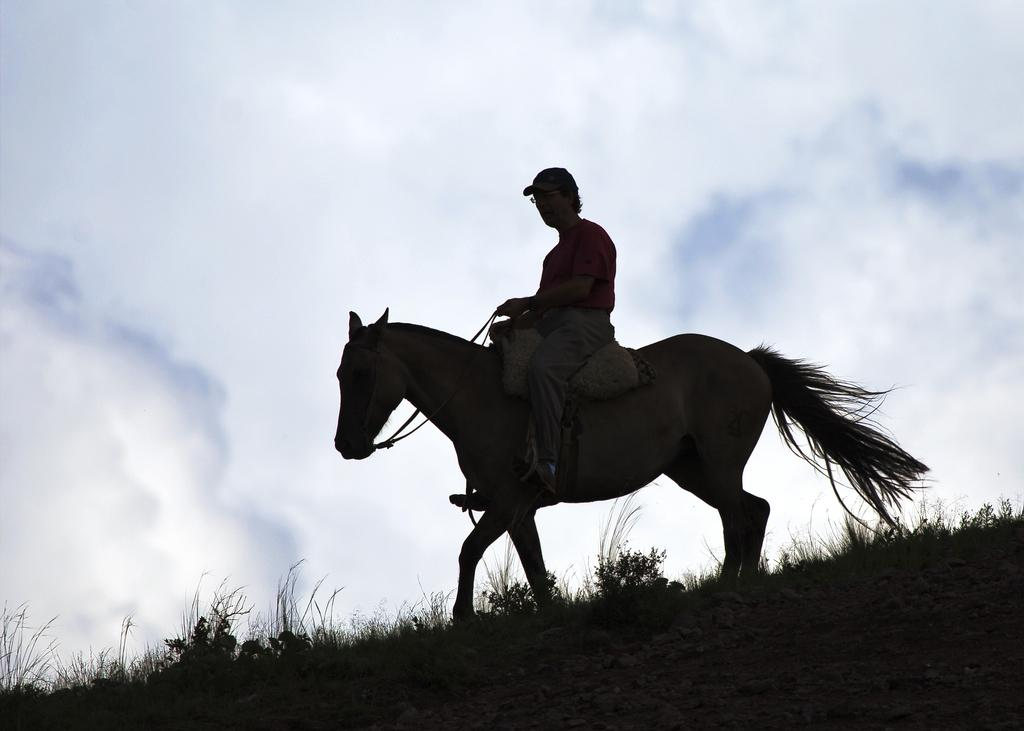What is the main subject of the image? The main subject of the image is a man. What is the man doing in the image? The man is sitting on a horse in the image. What is the surface beneath the man and the horse? There is a ground in the image. What type of headwear is the man wearing? The man is wearing a cap in the image. What can be seen in the sky in the background of the image? There are clouds in the sky in the background of the image. What type of hobbies does the crate in the image enjoy? There is no crate present in the image, so it is not possible to determine any hobbies. 